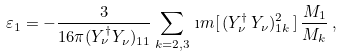<formula> <loc_0><loc_0><loc_500><loc_500>\varepsilon _ { 1 } = - \frac { 3 } { 1 6 \pi ( Y _ { \nu } ^ { \dag } Y _ { \nu } ) _ { 1 1 } } \sum _ { k = 2 , 3 } \, \i m [ \, ( Y _ { \nu } ^ { \dag } \, Y _ { \nu } ) _ { 1 k } ^ { 2 } \, ] \, \frac { M _ { 1 } } { M _ { k } } \, ,</formula> 